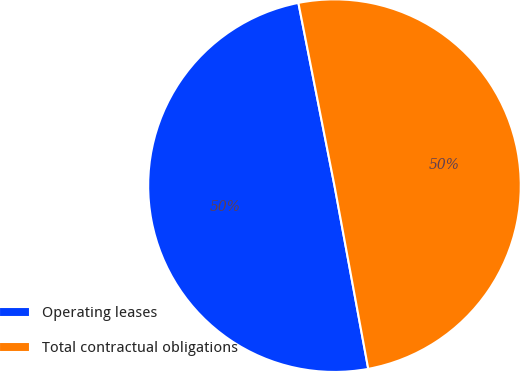Convert chart to OTSL. <chart><loc_0><loc_0><loc_500><loc_500><pie_chart><fcel>Operating leases<fcel>Total contractual obligations<nl><fcel>49.8%<fcel>50.2%<nl></chart> 